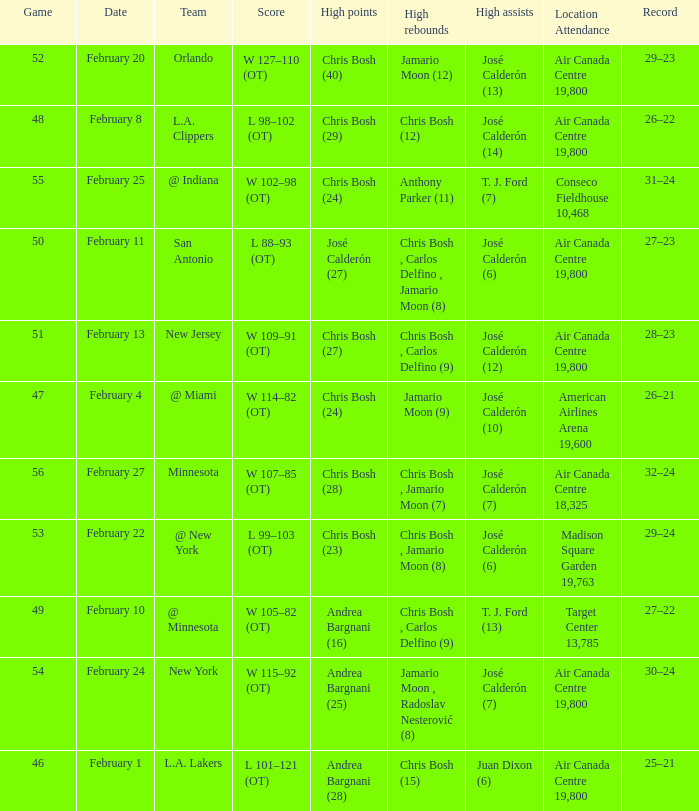What is the date of Game 50? February 11. 